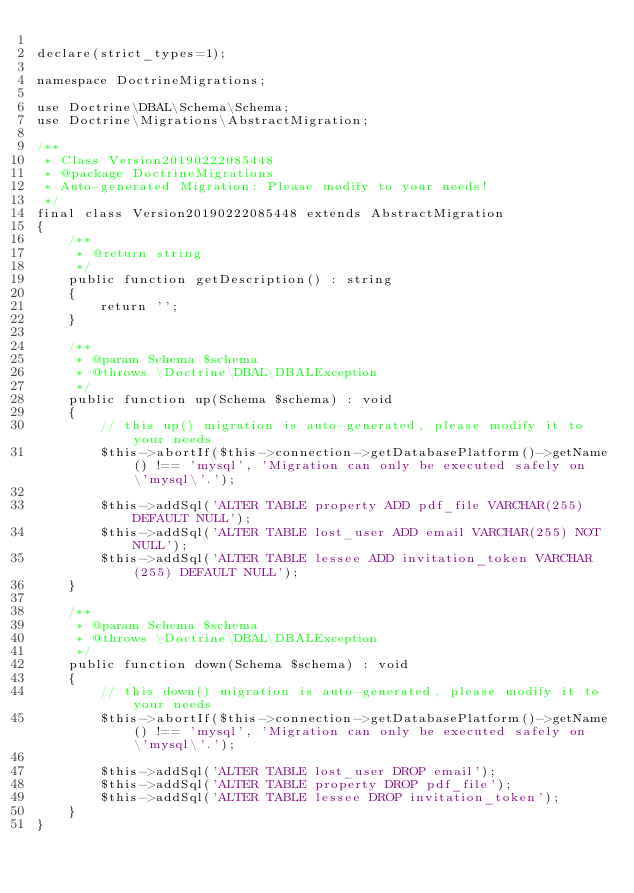Convert code to text. <code><loc_0><loc_0><loc_500><loc_500><_PHP_>
declare(strict_types=1);

namespace DoctrineMigrations;

use Doctrine\DBAL\Schema\Schema;
use Doctrine\Migrations\AbstractMigration;

/**
 * Class Version20190222085448
 * @package DoctrineMigrations
 * Auto-generated Migration: Please modify to your needs!
 */
final class Version20190222085448 extends AbstractMigration
{
    /**
     * @return string
     */
    public function getDescription() : string
    {
        return '';
    }

    /**
     * @param Schema $schema
     * @throws \Doctrine\DBAL\DBALException
     */
    public function up(Schema $schema) : void
    {
        // this up() migration is auto-generated, please modify it to your needs
        $this->abortIf($this->connection->getDatabasePlatform()->getName() !== 'mysql', 'Migration can only be executed safely on \'mysql\'.');

        $this->addSql('ALTER TABLE property ADD pdf_file VARCHAR(255) DEFAULT NULL');
        $this->addSql('ALTER TABLE lost_user ADD email VARCHAR(255) NOT NULL');
        $this->addSql('ALTER TABLE lessee ADD invitation_token VARCHAR(255) DEFAULT NULL');
    }

    /**
     * @param Schema $schema
     * @throws \Doctrine\DBAL\DBALException
     */
    public function down(Schema $schema) : void
    {
        // this down() migration is auto-generated, please modify it to your needs
        $this->abortIf($this->connection->getDatabasePlatform()->getName() !== 'mysql', 'Migration can only be executed safely on \'mysql\'.');

        $this->addSql('ALTER TABLE lost_user DROP email');
        $this->addSql('ALTER TABLE property DROP pdf_file');
        $this->addSql('ALTER TABLE lessee DROP invitation_token');
    }
}
</code> 